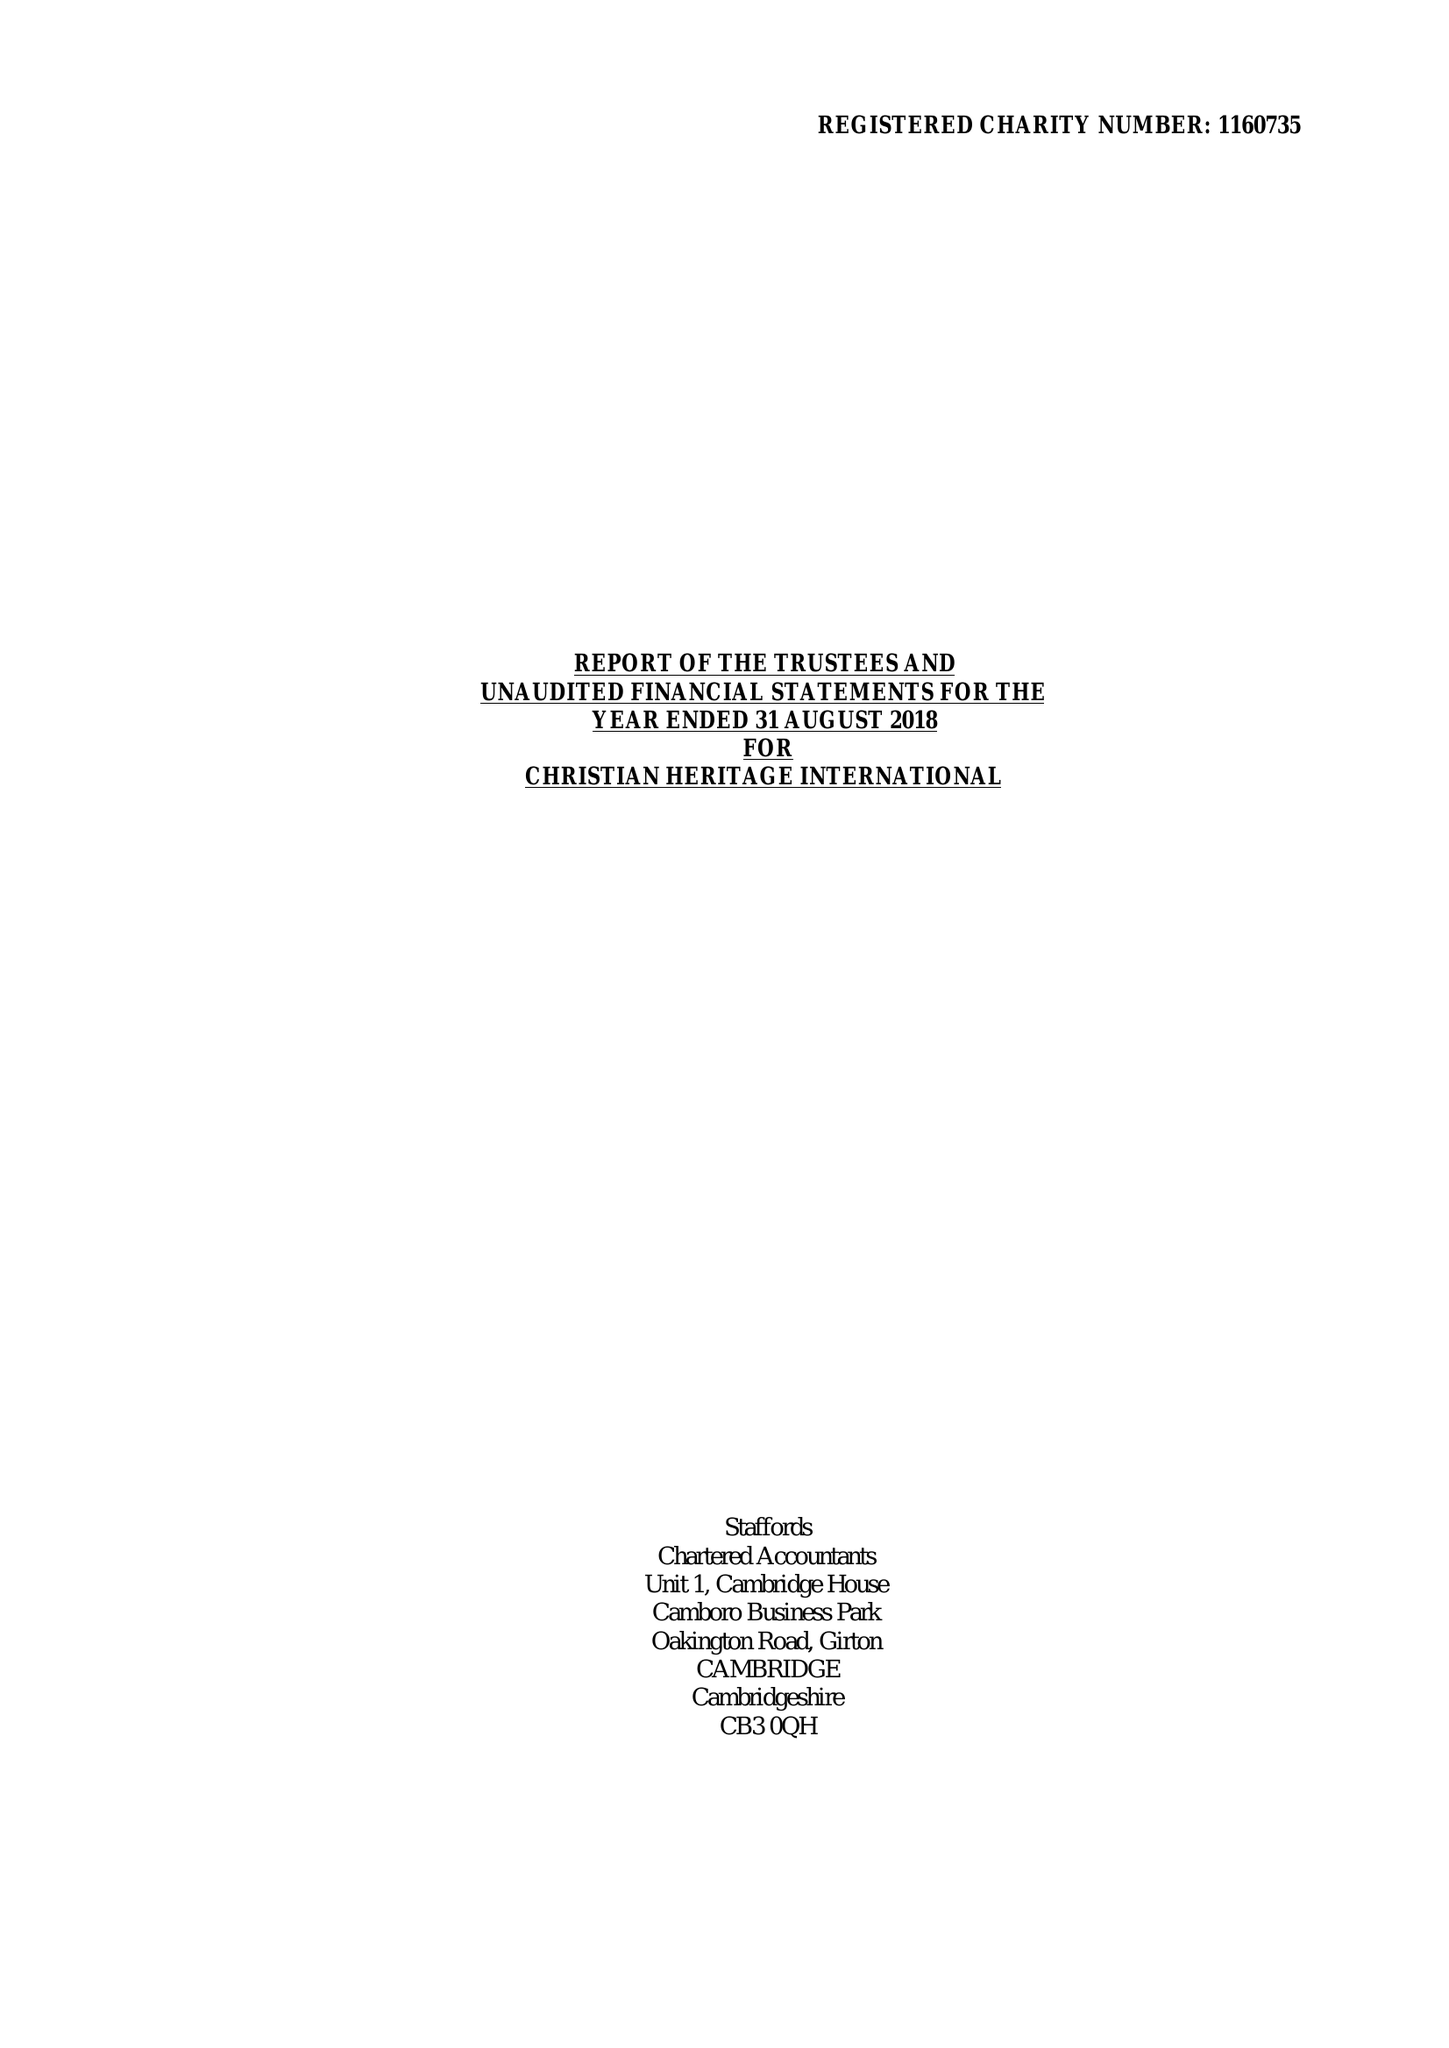What is the value for the charity_name?
Answer the question using a single word or phrase. Christian Heritage International 